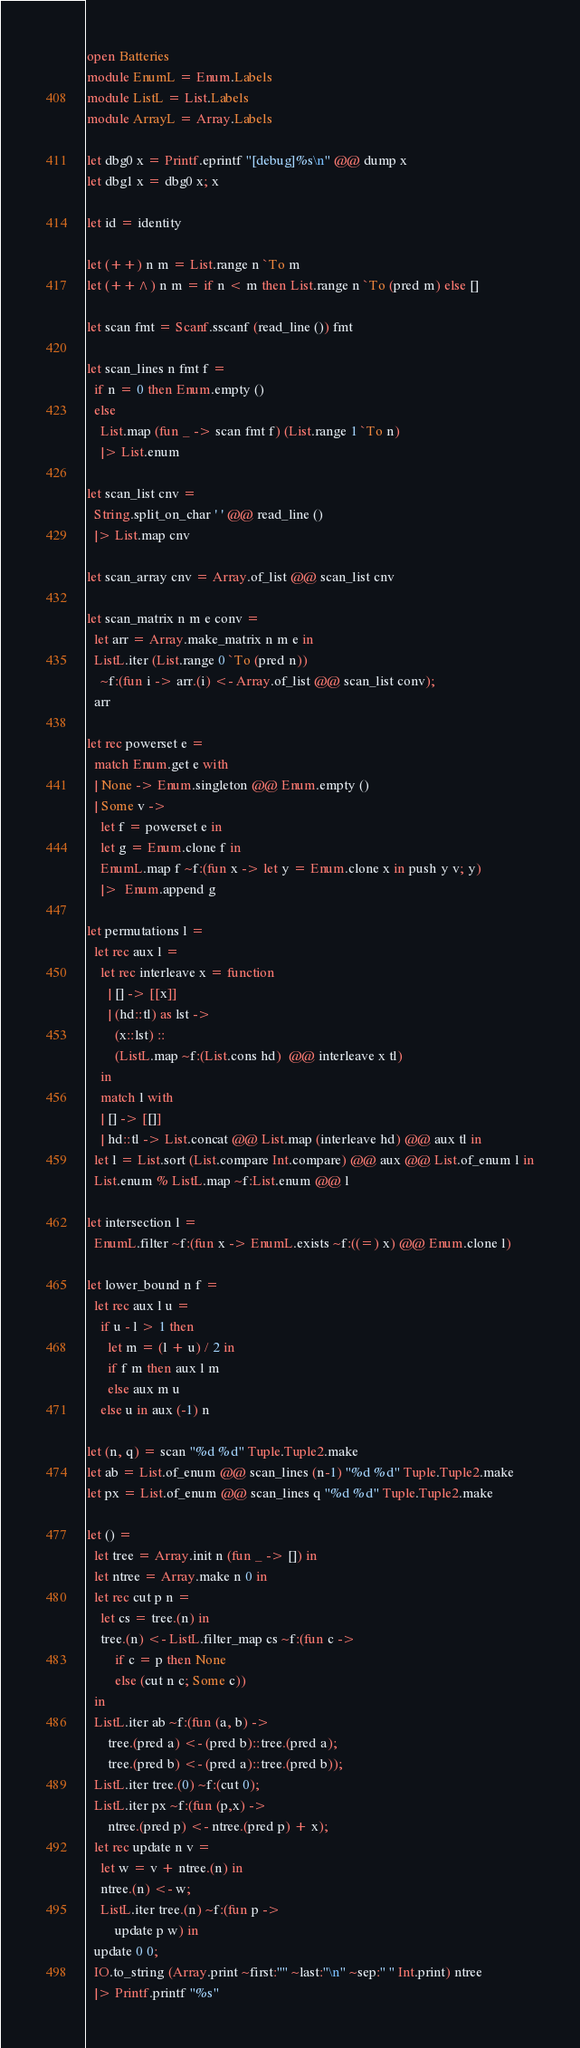Convert code to text. <code><loc_0><loc_0><loc_500><loc_500><_OCaml_>open Batteries
module EnumL = Enum.Labels
module ListL = List.Labels
module ArrayL = Array.Labels

let dbg0 x = Printf.eprintf "[debug]%s\n" @@ dump x
let dbg1 x = dbg0 x; x

let id = identity

let (++) n m = List.range n `To m
let (++^) n m = if n < m then List.range n `To (pred m) else []

let scan fmt = Scanf.sscanf (read_line ()) fmt

let scan_lines n fmt f =
  if n = 0 then Enum.empty ()
  else
    List.map (fun _ -> scan fmt f) (List.range 1 `To n)
    |> List.enum

let scan_list cnv =
  String.split_on_char ' ' @@ read_line ()
  |> List.map cnv

let scan_array cnv = Array.of_list @@ scan_list cnv

let scan_matrix n m e conv =
  let arr = Array.make_matrix n m e in
  ListL.iter (List.range 0 `To (pred n))
    ~f:(fun i -> arr.(i) <- Array.of_list @@ scan_list conv);
  arr

let rec powerset e =
  match Enum.get e with
  | None -> Enum.singleton @@ Enum.empty ()
  | Some v ->
    let f = powerset e in
    let g = Enum.clone f in
    EnumL.map f ~f:(fun x -> let y = Enum.clone x in push y v; y)
    |>  Enum.append g

let permutations l =
  let rec aux l =
    let rec interleave x = function
      | [] -> [[x]]
      | (hd::tl) as lst ->
        (x::lst) ::
        (ListL.map ~f:(List.cons hd)  @@ interleave x tl)
    in
    match l with
    | [] -> [[]]
    | hd::tl -> List.concat @@ List.map (interleave hd) @@ aux tl in
  let l = List.sort (List.compare Int.compare) @@ aux @@ List.of_enum l in
  List.enum % ListL.map ~f:List.enum @@ l

let intersection l =
  EnumL.filter ~f:(fun x -> EnumL.exists ~f:((=) x) @@ Enum.clone l)

let lower_bound n f =
  let rec aux l u =
    if u - l > 1 then
      let m = (l + u) / 2 in
      if f m then aux l m
      else aux m u
    else u in aux (-1) n

let (n, q) = scan "%d %d" Tuple.Tuple2.make
let ab = List.of_enum @@ scan_lines (n-1) "%d %d" Tuple.Tuple2.make
let px = List.of_enum @@ scan_lines q "%d %d" Tuple.Tuple2.make

let () =
  let tree = Array.init n (fun _ -> []) in
  let ntree = Array.make n 0 in
  let rec cut p n =
    let cs = tree.(n) in
    tree.(n) <- ListL.filter_map cs ~f:(fun c ->
        if c = p then None
        else (cut n c; Some c))
  in
  ListL.iter ab ~f:(fun (a, b) ->
      tree.(pred a) <- (pred b)::tree.(pred a);
      tree.(pred b) <- (pred a)::tree.(pred b));
  ListL.iter tree.(0) ~f:(cut 0);
  ListL.iter px ~f:(fun (p,x) ->
      ntree.(pred p) <- ntree.(pred p) + x);
  let rec update n v =
    let w = v + ntree.(n) in
    ntree.(n) <- w;
    ListL.iter tree.(n) ~f:(fun p ->
        update p w) in
  update 0 0;
  IO.to_string (Array.print ~first:"" ~last:"\n" ~sep:" " Int.print) ntree
  |> Printf.printf "%s"
</code> 